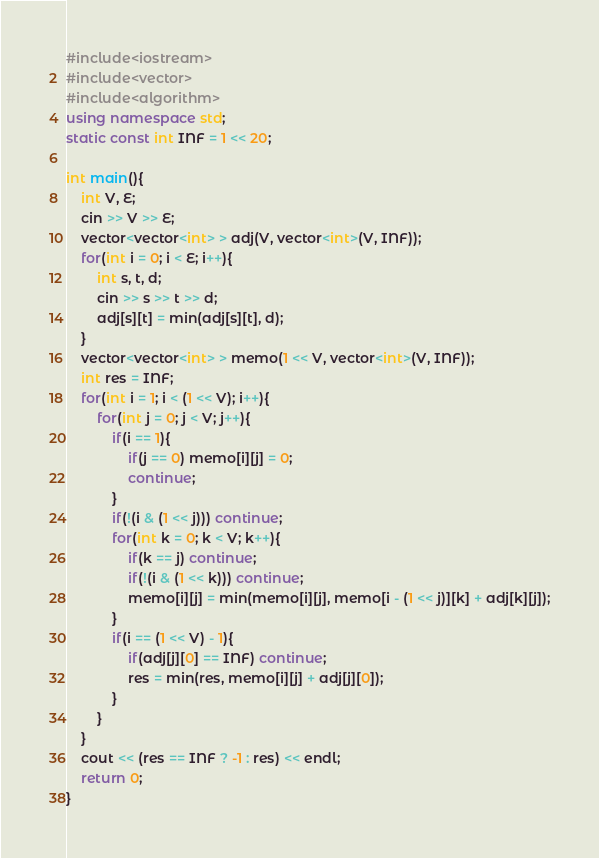Convert code to text. <code><loc_0><loc_0><loc_500><loc_500><_C++_>#include<iostream>
#include<vector>
#include<algorithm>
using namespace std;
static const int INF = 1 << 20;

int main(){
	int V, E;
	cin >> V >> E;
	vector<vector<int> > adj(V, vector<int>(V, INF));
	for(int i = 0; i < E; i++){
		int s, t, d;
		cin >> s >> t >> d;
		adj[s][t] = min(adj[s][t], d);
	}
	vector<vector<int> > memo(1 << V, vector<int>(V, INF));
	int res = INF;
	for(int i = 1; i < (1 << V); i++){
		for(int j = 0; j < V; j++){
			if(i == 1){
				if(j == 0) memo[i][j] = 0;
				continue;
			}
			if(!(i & (1 << j))) continue;
			for(int k = 0; k < V; k++){
				if(k == j) continue;
				if(!(i & (1 << k))) continue;
				memo[i][j] = min(memo[i][j], memo[i - (1 << j)][k] + adj[k][j]);
			}
			if(i == (1 << V) - 1){
				if(adj[j][0] == INF) continue;
				res = min(res, memo[i][j] + adj[j][0]);
			}
		}
	}
	cout << (res == INF ? -1 : res) << endl;
	return 0;
}

</code> 